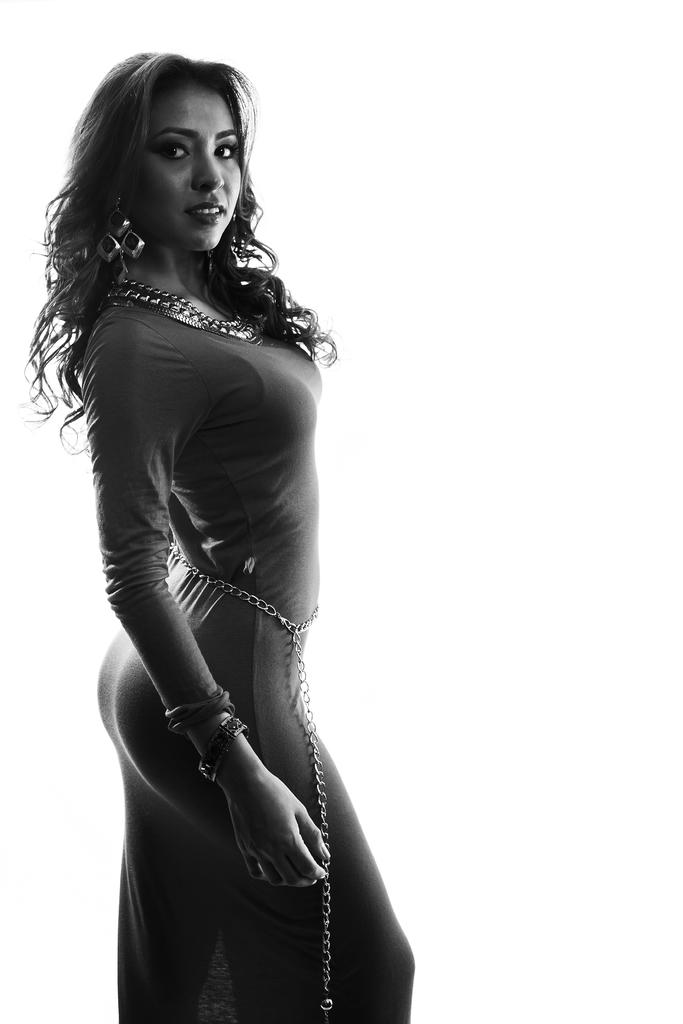Who is present in the image? There is a woman in the image. What is the woman doing in the image? The woman is watching and smiling. What accessories is the woman wearing in the image? The woman is wearing earrings, a chain, and waist jewelry. How many potatoes can be seen in the image? There are no potatoes present in the image. What type of muscle is visible on the woman's arm in the image? There is no muscle visible on the woman's arm in the image. 